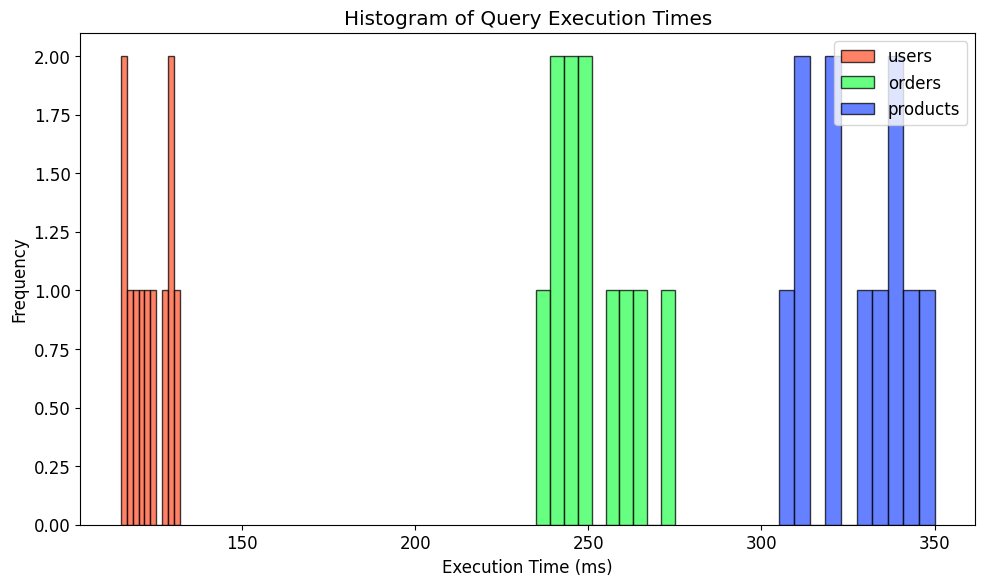What is the overall trend in query execution times for the 'users' table compared to the 'orders' table? To answer this, we need to observe the distribution of execution times for both the 'users' and 'orders' tables. The 'users' table generally has lower execution times compared to the 'orders' table, as visible from the positions of their histograms.
Answer: 'users' table has lower execution times than 'orders' table Which table has the most variable (widest spread of) execution times? To determine this, examine the range of the execution times represented by the histograms for each table. The 'products' table shows a wider spread of execution times compared to the 'users' and 'orders' tables.
Answer: 'products' table What is the approximate average execution time for the 'orders' table? Estimate the center of the 'orders' histogram. The 'orders' table has execution times mostly centered around 250 ms.
Answer: Around 250 ms How do the peak frequencies (highest bars) of the 'users' and 'products' tables compare? Look at the tallest bars in the histograms for 'users' and 'products' tables. The peak frequency for the 'users' table is higher than that of the 'products' table.
Answer: 'users' table has a higher peak frequency For which table is the execution time more consistent, and how can you tell? A more consistent execution time implies less spread in the histogram. The 'users' table has a narrower range of execution times compared to the others, indicating more consistency.
Answer: 'users' table is more consistent How does the distribution of query execution times for the 'products' table compare to the 'users' and 'orders' tables? The 'products' table has a wider distribution and higher execution times on average. The 'users' and 'orders' tables have narrower distributions with lower execution times.
Answer: 'products' table has a wider and higher execution time distribution What is the typical range of query execution times for the 'users' table? Examine the horizontal extent of the 'users' histogram. The 'users' table query execution times range approximately between 115 ms and 132 ms.
Answer: Between 115 ms and 132 ms Which table has the highest overall query execution times, and what is its approximate range? Look at the histograms and see where the highest execution times fall. The 'products' table clearly has the highest execution times, ranging from roughly 305 ms to 350 ms.
Answer: 'products' table, 305 ms to 350 ms If you were to improve the performance of one table based on query execution times, which one would you prioritize and why? Focus on the table with the longest average execution times. Based on the histogram, the 'products' table consistently has higher and more variable execution times than the others, indicating it may benefit most from performance improvements.
Answer: Prioritize 'products' table 